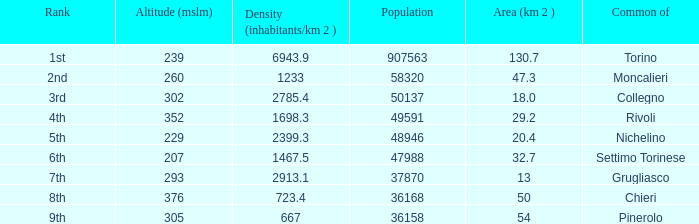What rank is the common with an area of 47.3 km^2? 2nd. 